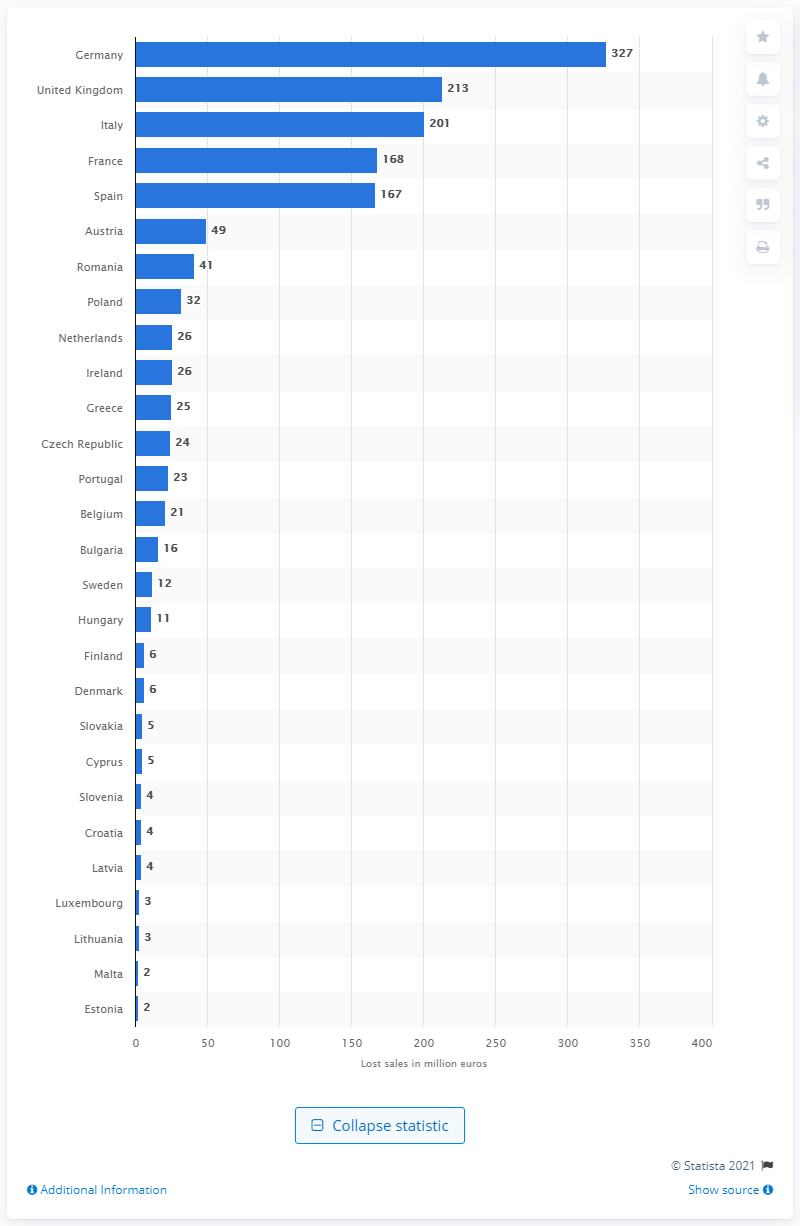Point out several critical features in this image. In 2015, Germany suffered the largest decline in sales among all countries. In 2015, Germany lost an estimated 327 million dollars in sales due to the counterfeiting of toys and games. 